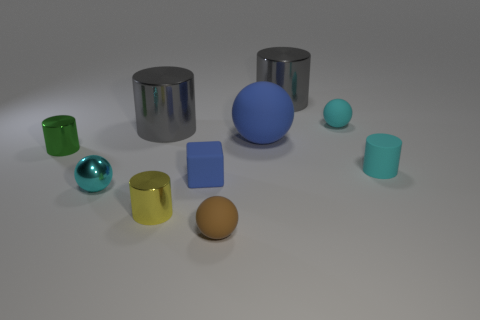Subtract all tiny spheres. How many spheres are left? 1 Subtract 1 cylinders. How many cylinders are left? 4 Subtract all yellow cylinders. How many cylinders are left? 4 Subtract all balls. How many objects are left? 6 Subtract all gray blocks. How many blue spheres are left? 1 Subtract 1 blue blocks. How many objects are left? 9 Subtract all yellow spheres. Subtract all red cylinders. How many spheres are left? 4 Subtract all tiny yellow metal cylinders. Subtract all big blue balls. How many objects are left? 8 Add 7 large gray metal cylinders. How many large gray metal cylinders are left? 9 Add 8 tiny cyan matte things. How many tiny cyan matte things exist? 10 